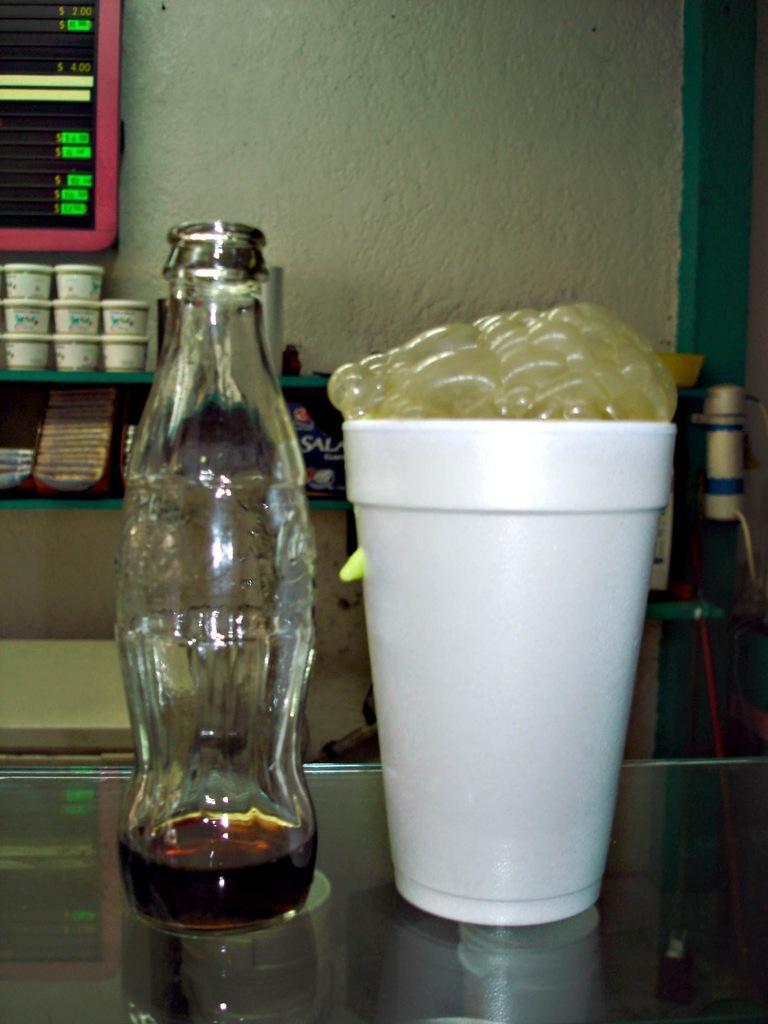Please provide a concise description of this image. In this image we can see a bottle and a cup on the table and also we can see few boxes in the background. 